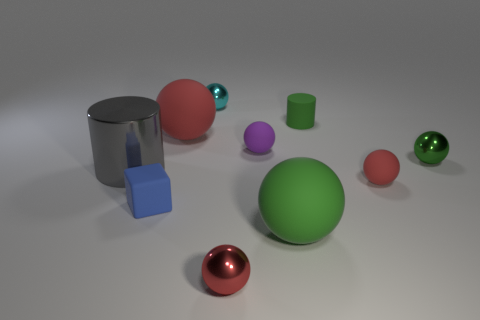How many spheres are there in total in this image, and which has the largest diameter? There are a total of five spheres visible in the image. The green one in the center has the largest diameter amongst them, dominating the scene with its size. 